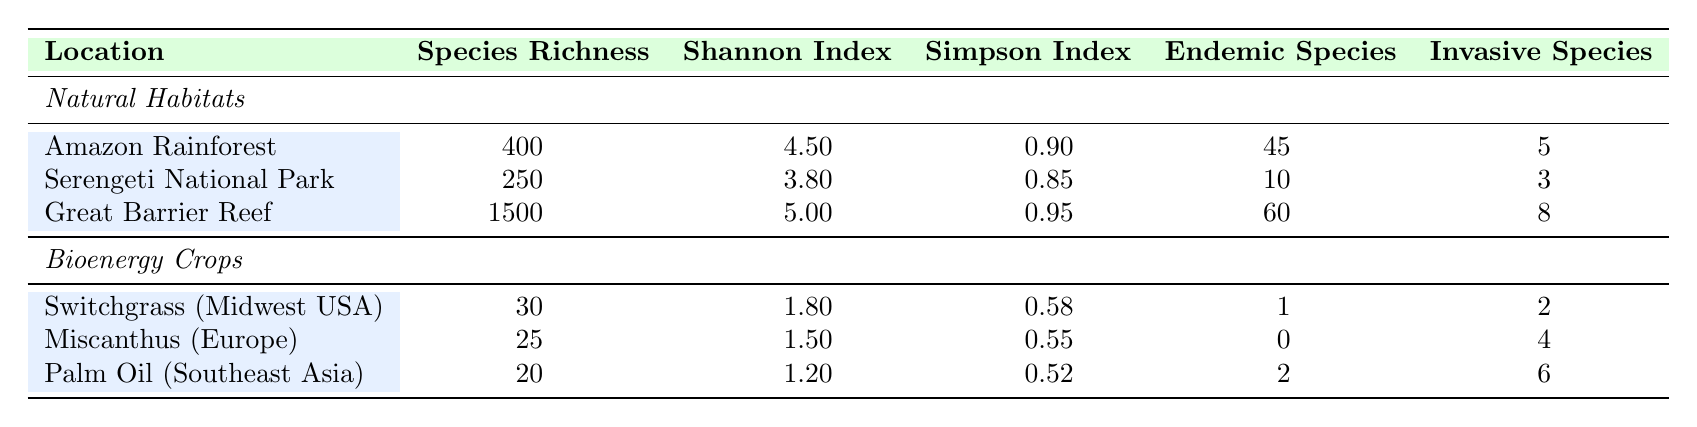What is the species richness in the Amazon Rainforest? The species richness for the Amazon Rainforest is provided in the table as 400.
Answer: 400 Which location has the highest Shannon diversity index? By comparing the values for the Shannon diversity index, the Great Barrier Reef has the highest value at 5.0.
Answer: Great Barrier Reef What is the average species richness of the bioenergy crops listed? The species richness values for the bioenergy crops are 30, 25, and 20. Adding them gives 30 + 25 + 20 = 75, and there are 3 values, so the average is 75/3 = 25.
Answer: 25 How many endemic species are found in the Miscanthus bioenergy crop area? The table shows that the number of endemic species in the Miscanthus bioenergy crop area is 0.
Answer: 0 Is it true that the Serengeti National Park has more invasive species than the Switchgrass area? The Serengeti National Park has 3 invasive species while the Switchgrass area has 2. Since 3 > 2, the statement is true.
Answer: True What is the total number of invasive species across all listed locations? To find the total number of invasive species, we add the values from the table: 5 (Amazon) + 3 (Serengeti) + 8 (Great Barrier) + 2 (Switchgrass) + 4 (Miscanthus) + 6 (Palm Oil) = 28.
Answer: 28 Which natural habitat has the lowest species richness? The species richness values for the natural habitats are 400 (Amazon), 250 (Serengeti), and 1500 (Great Barrier Reef). The lowest among these is 250, found in the Serengeti National Park.
Answer: Serengeti National Park If we compare the Simpson diversity index of bioenergy crops and natural habitats, which category is generally higher? The Simpson diversity indexes for bioenergy crops are 0.58, 0.55, and 0.52, while for natural habitats they are 0.90, 0.85, and 0.95. All values for natural habitats are higher than those for bioenergy crops.
Answer: Natural habitats What is the difference in endemic species between the Great Barrier Reef and Palm Oil plantations? The Great Barrier Reef has 60 endemic species, while Palm Oil plantations have 2. The difference is 60 - 2 = 58.
Answer: 58 Does the Amazon Rainforest have more species richness than any of the bioenergy crop areas? The Amazon Rainforest has 400 species richness while the bioenergy crop areas have 30, 25, and 20. Since 400 > 30, 25, or 20, it is true.
Answer: Yes 